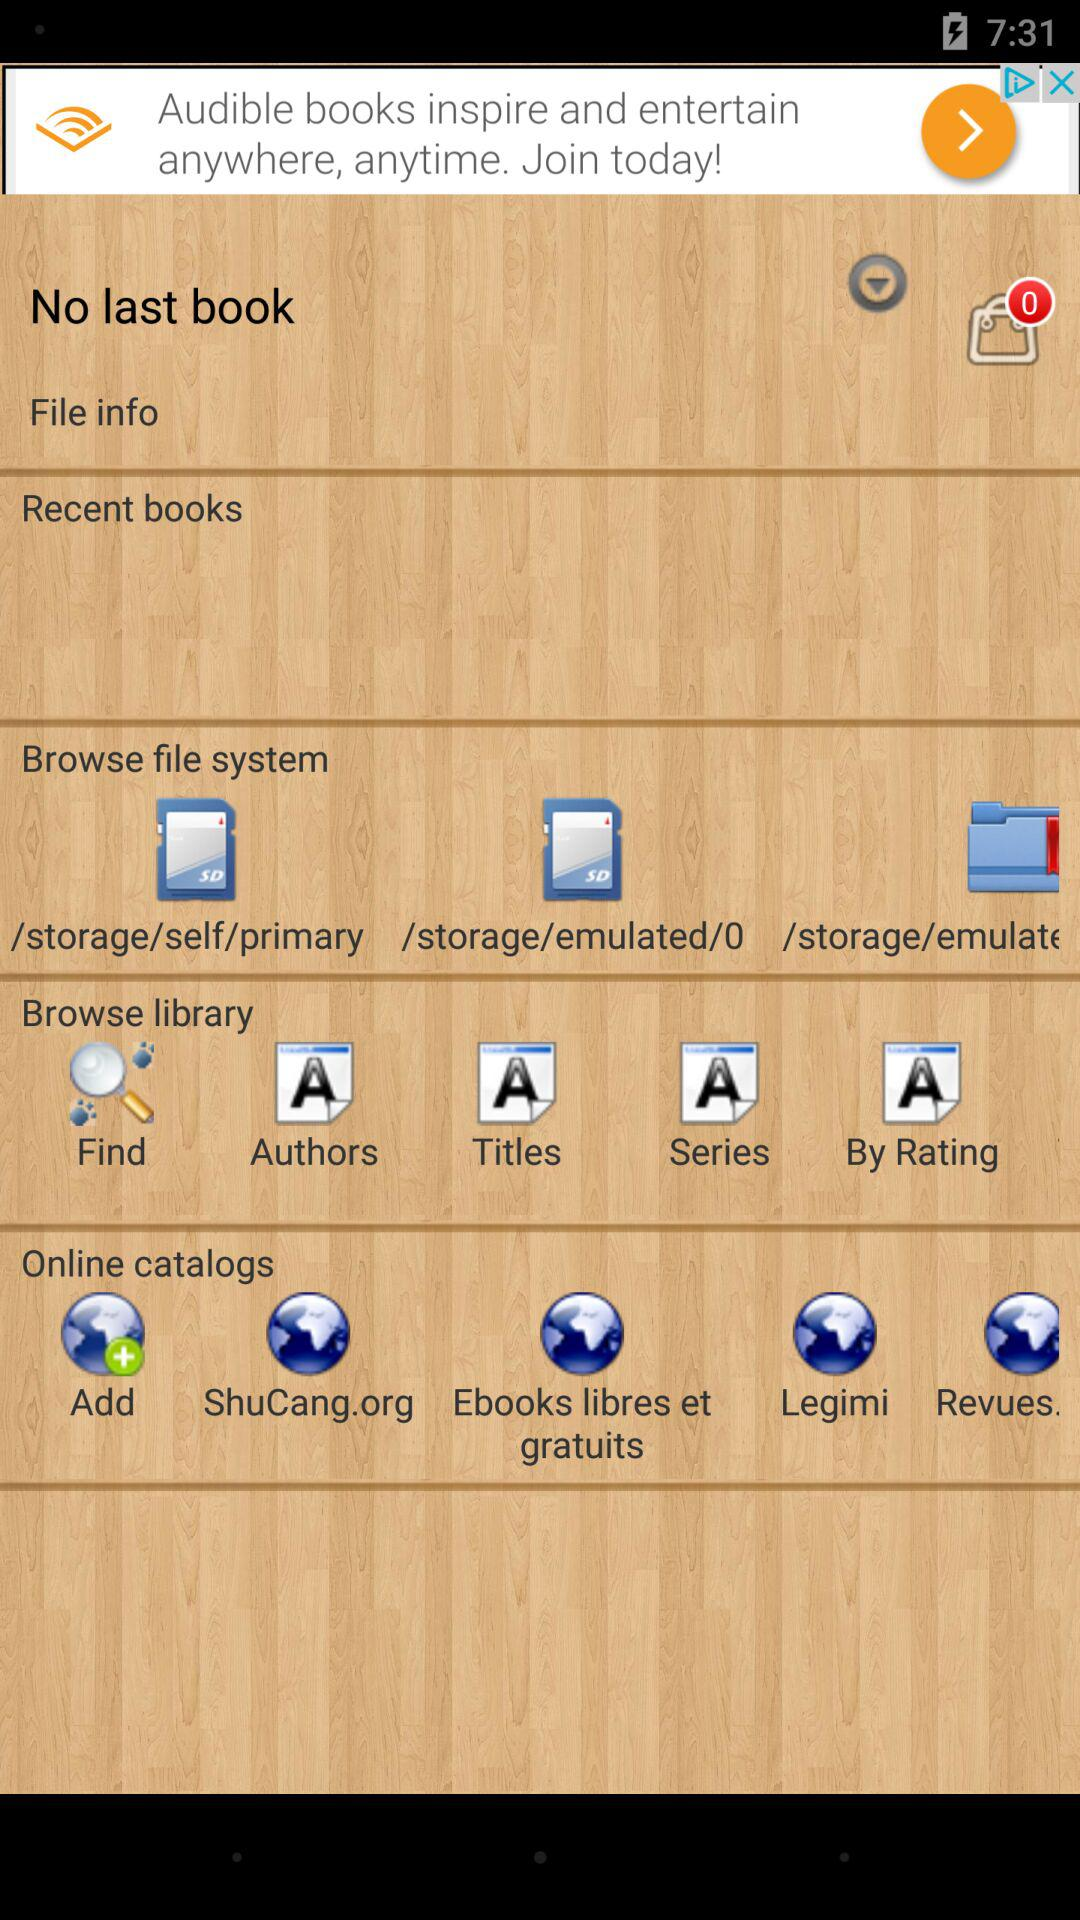How many recent books are there?
When the provided information is insufficient, respond with <no answer>. <no answer> 